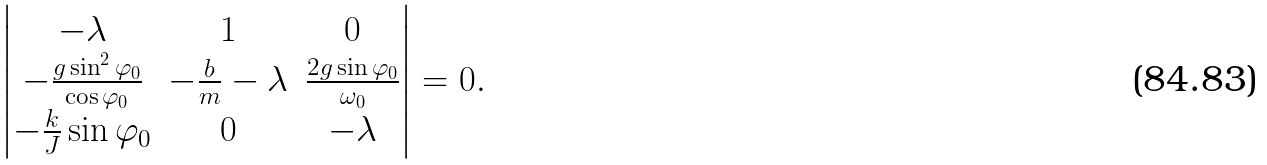Convert formula to latex. <formula><loc_0><loc_0><loc_500><loc_500>\begin{vmatrix} - \lambda & 1 & 0 \\ - \frac { g \sin ^ { 2 } \varphi _ { 0 } } { \cos \varphi _ { 0 } } & - \frac { b } { m } - \lambda & \frac { 2 g \sin \varphi _ { 0 } } { \omega _ { 0 } } \\ - \frac { k } { J } \sin \varphi _ { 0 } & 0 & - \lambda \end{vmatrix} = 0 .</formula> 